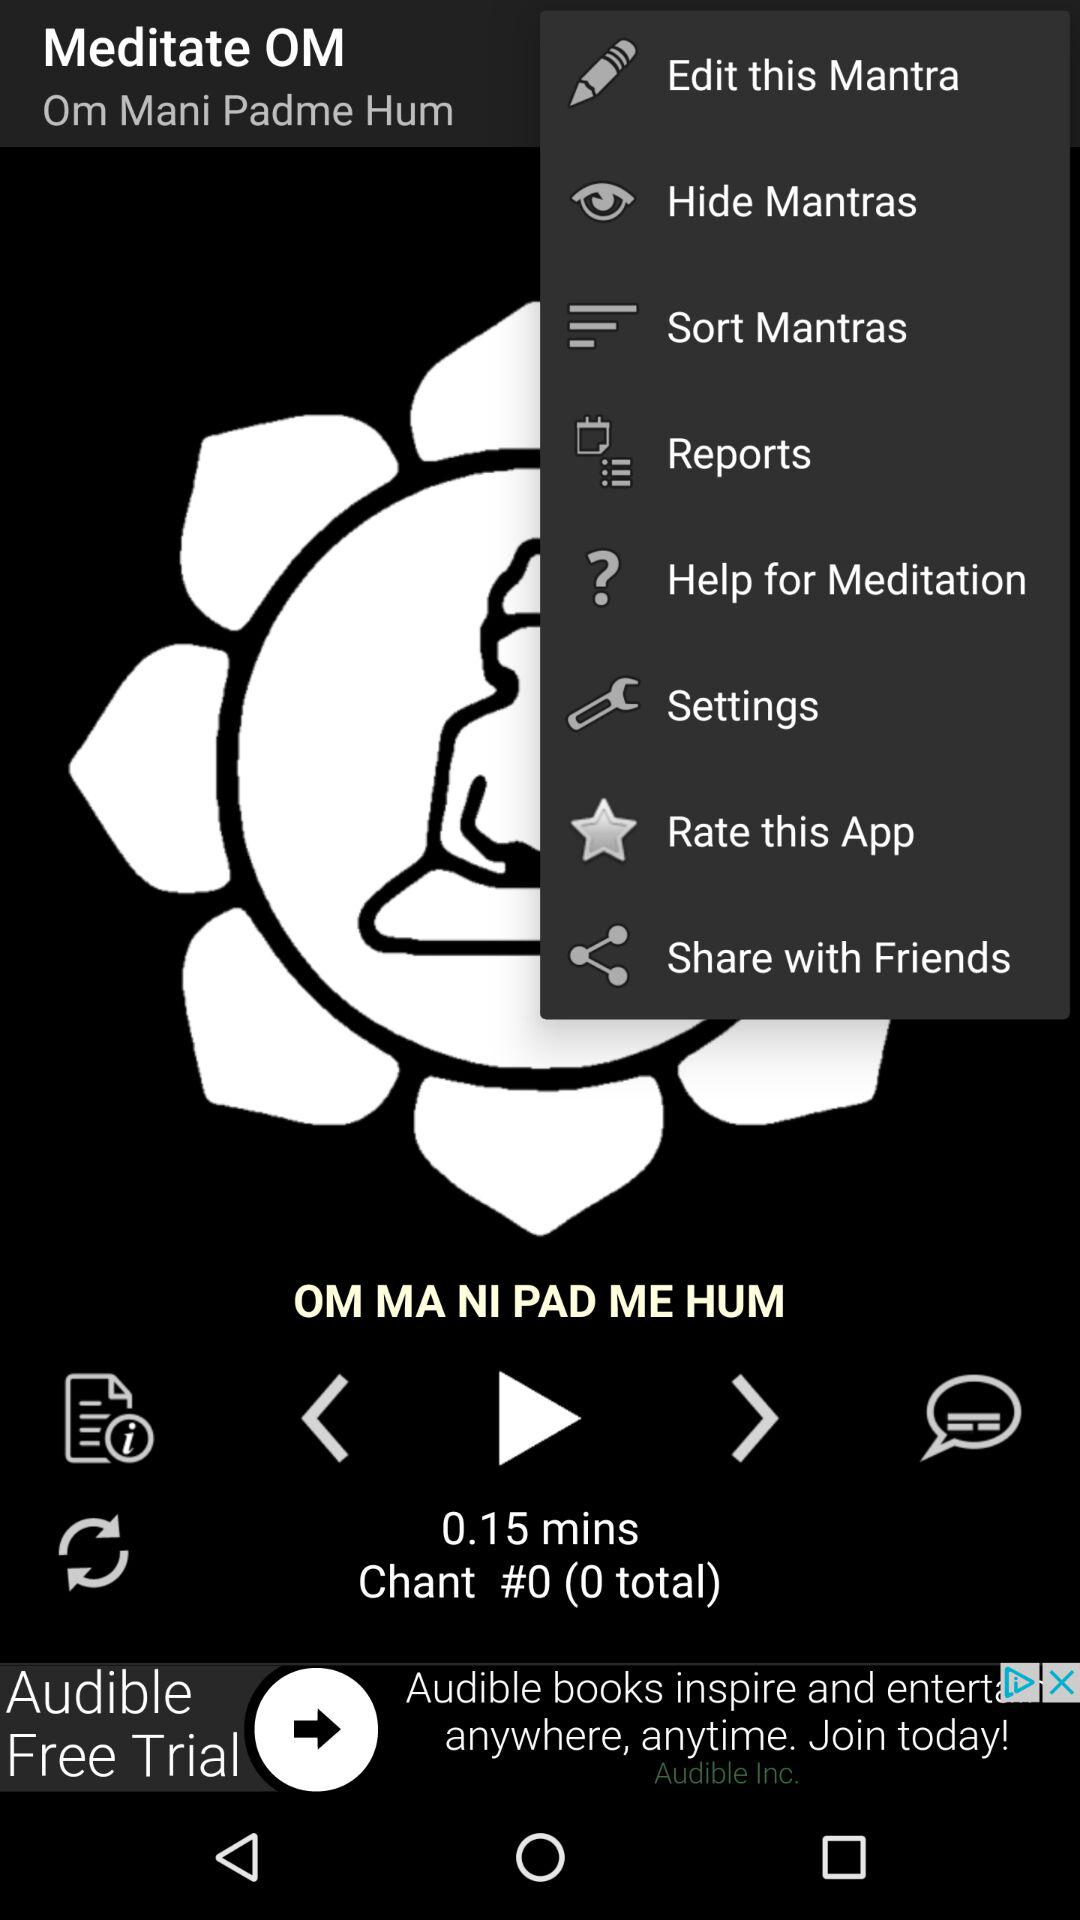What is the time duration of the song "OM MA NI PAD ME HUM"? The time duration is 0.15 minutes. 